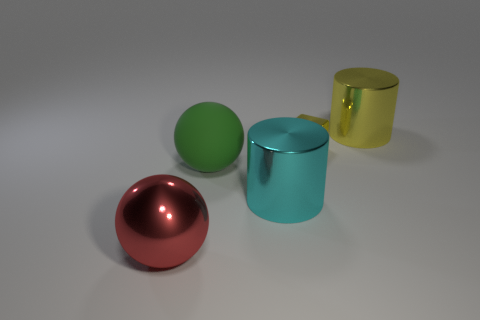Is there an indication of the size of these objects? While there's no direct reference point in the image to accurately determine the scale, the soft shadows and proportionate spacing between objects suggest that they could be the size of small household items.  If these objects were part of a collection, what might that collection be? If these objects were part of a collection, they might belong to a set that showcases geometric shapes and materials, perhaps for educational purposes or as decorative art pieces that exemplify minimalist design. 